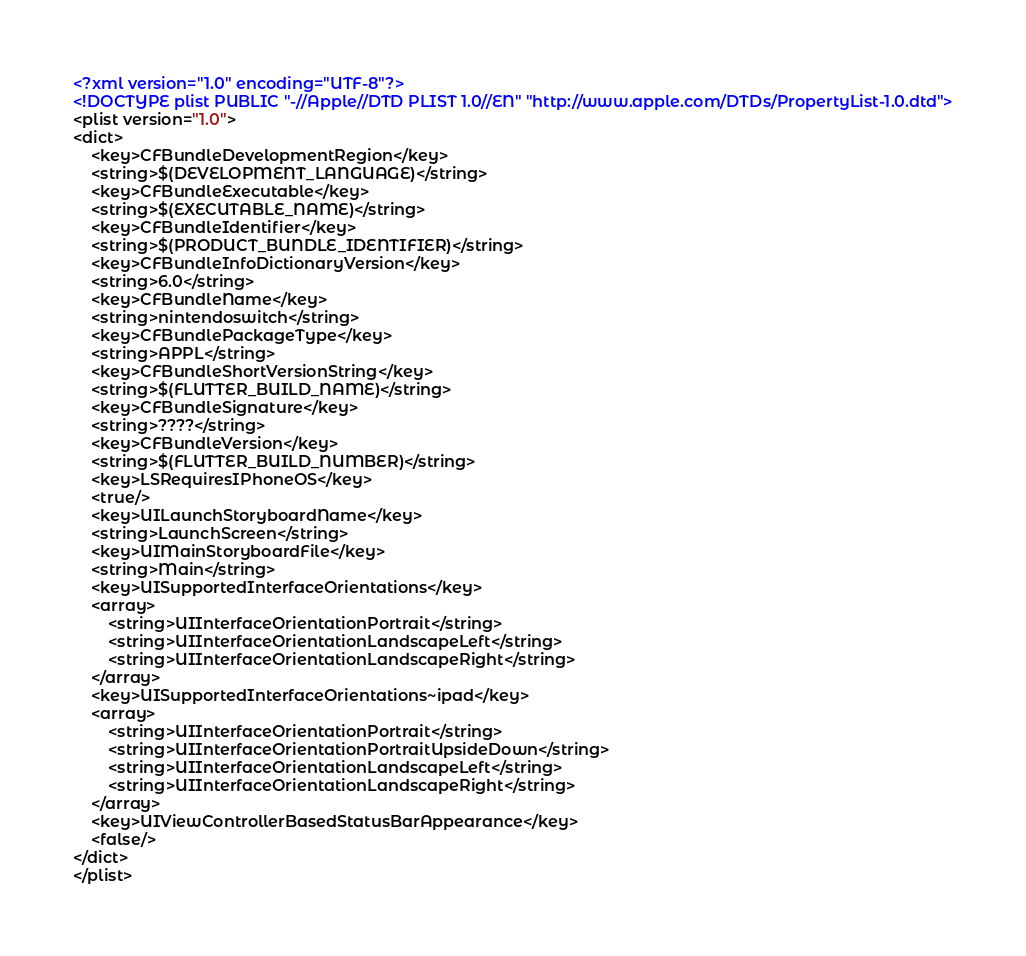<code> <loc_0><loc_0><loc_500><loc_500><_XML_><?xml version="1.0" encoding="UTF-8"?>
<!DOCTYPE plist PUBLIC "-//Apple//DTD PLIST 1.0//EN" "http://www.apple.com/DTDs/PropertyList-1.0.dtd">
<plist version="1.0">
<dict>
	<key>CFBundleDevelopmentRegion</key>
	<string>$(DEVELOPMENT_LANGUAGE)</string>
	<key>CFBundleExecutable</key>
	<string>$(EXECUTABLE_NAME)</string>
	<key>CFBundleIdentifier</key>
	<string>$(PRODUCT_BUNDLE_IDENTIFIER)</string>
	<key>CFBundleInfoDictionaryVersion</key>
	<string>6.0</string>
	<key>CFBundleName</key>
	<string>nintendoswitch</string>
	<key>CFBundlePackageType</key>
	<string>APPL</string>
	<key>CFBundleShortVersionString</key>
	<string>$(FLUTTER_BUILD_NAME)</string>
	<key>CFBundleSignature</key>
	<string>????</string>
	<key>CFBundleVersion</key>
	<string>$(FLUTTER_BUILD_NUMBER)</string>
	<key>LSRequiresIPhoneOS</key>
	<true/>
	<key>UILaunchStoryboardName</key>
	<string>LaunchScreen</string>
	<key>UIMainStoryboardFile</key>
	<string>Main</string>
	<key>UISupportedInterfaceOrientations</key>
	<array>
		<string>UIInterfaceOrientationPortrait</string>
		<string>UIInterfaceOrientationLandscapeLeft</string>
		<string>UIInterfaceOrientationLandscapeRight</string>
	</array>
	<key>UISupportedInterfaceOrientations~ipad</key>
	<array>
		<string>UIInterfaceOrientationPortrait</string>
		<string>UIInterfaceOrientationPortraitUpsideDown</string>
		<string>UIInterfaceOrientationLandscapeLeft</string>
		<string>UIInterfaceOrientationLandscapeRight</string>
	</array>
	<key>UIViewControllerBasedStatusBarAppearance</key>
	<false/>
</dict>
</plist>
</code> 